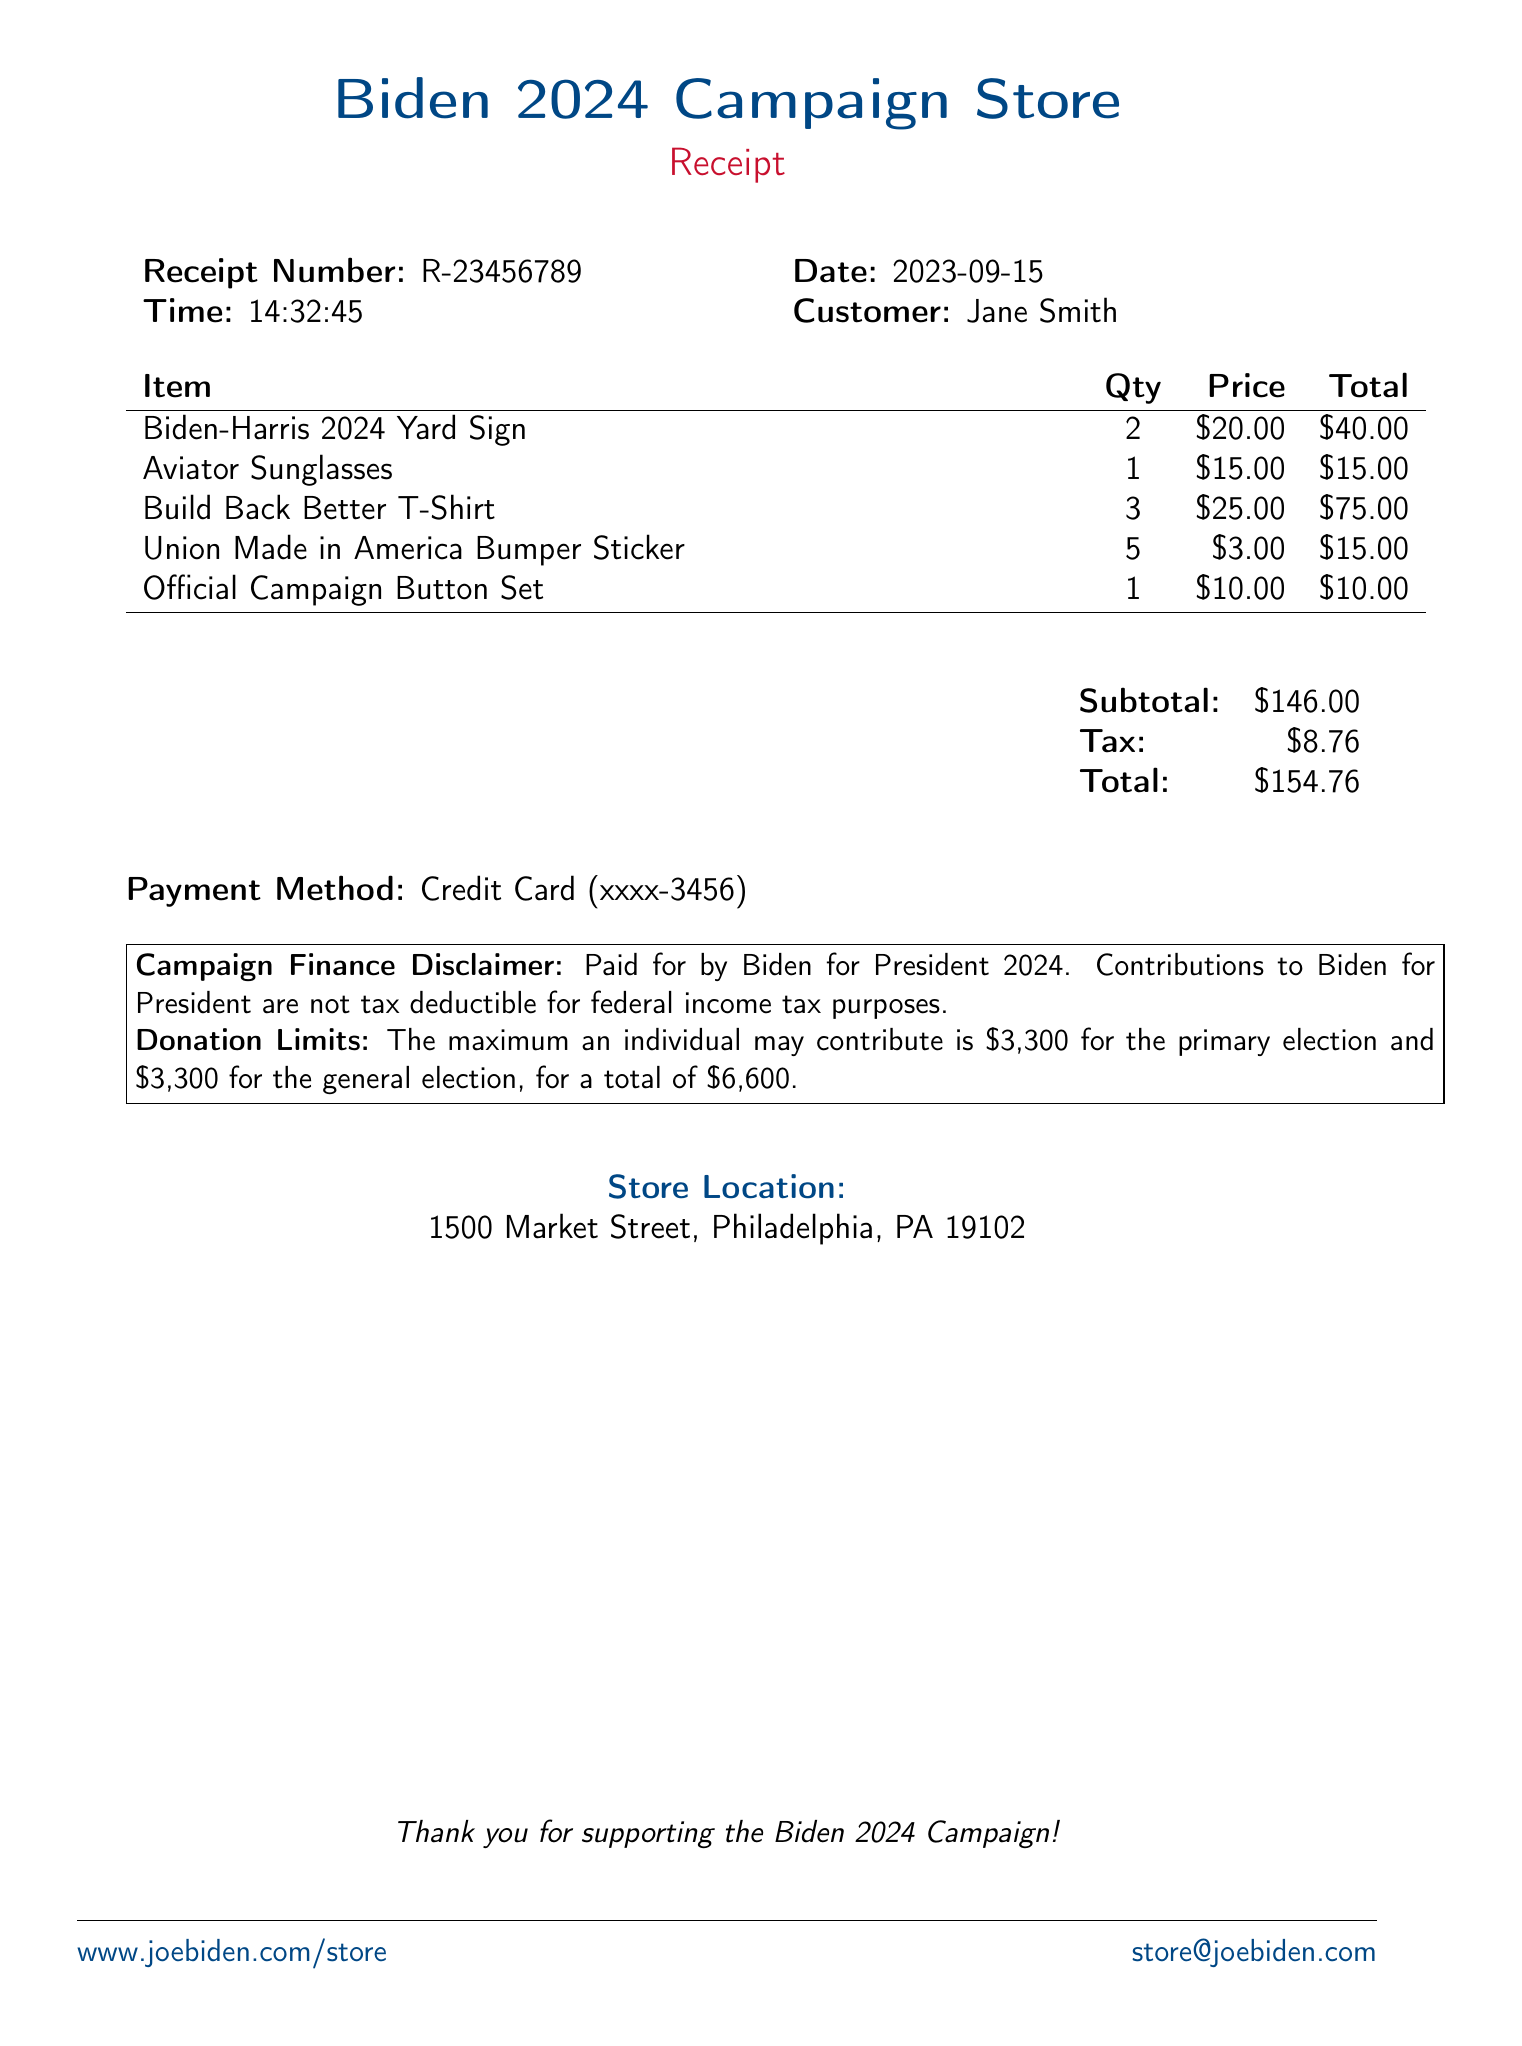What is the store name? The store name is mentioned at the top of the document as "Biden 2024 Campaign Store."
Answer: Biden 2024 Campaign Store What is the receipt number? The receipt number is listed in the document as "R-23456789."
Answer: R-23456789 What date was the purchase made? The date of the purchase is provided in the document, which states "2023-09-15."
Answer: 2023-09-15 How much did the "Build Back Better T-Shirt" cost per item? The document specifies that the price for the "Build Back Better T-Shirt" is $25.00.
Answer: $25.00 What is the total amount spent? The total amount is calculated from the subtotal and tax and is stated as $154.76 in the document.
Answer: $154.76 How many items were purchased in total? By summing the quantities listed for each item, the document indicates a total of 12 items purchased.
Answer: 12 What payment method was used for the transaction? The payment method is mentioned as "Credit Card" in the receipt.
Answer: Credit Card What is the maximum amount an individual may contribute to the campaign? The contribution limits state that the maximum is $3,300 for both the primary and general elections.
Answer: $3,300 Where is the store located? The document lists the store location as "1500 Market Street, Philadelphia, PA 19102."
Answer: 1500 Market Street, Philadelphia, PA 19102 What is the customer name on the receipt? The customer name is provided as "Jane Smith" in the document.
Answer: Jane Smith 